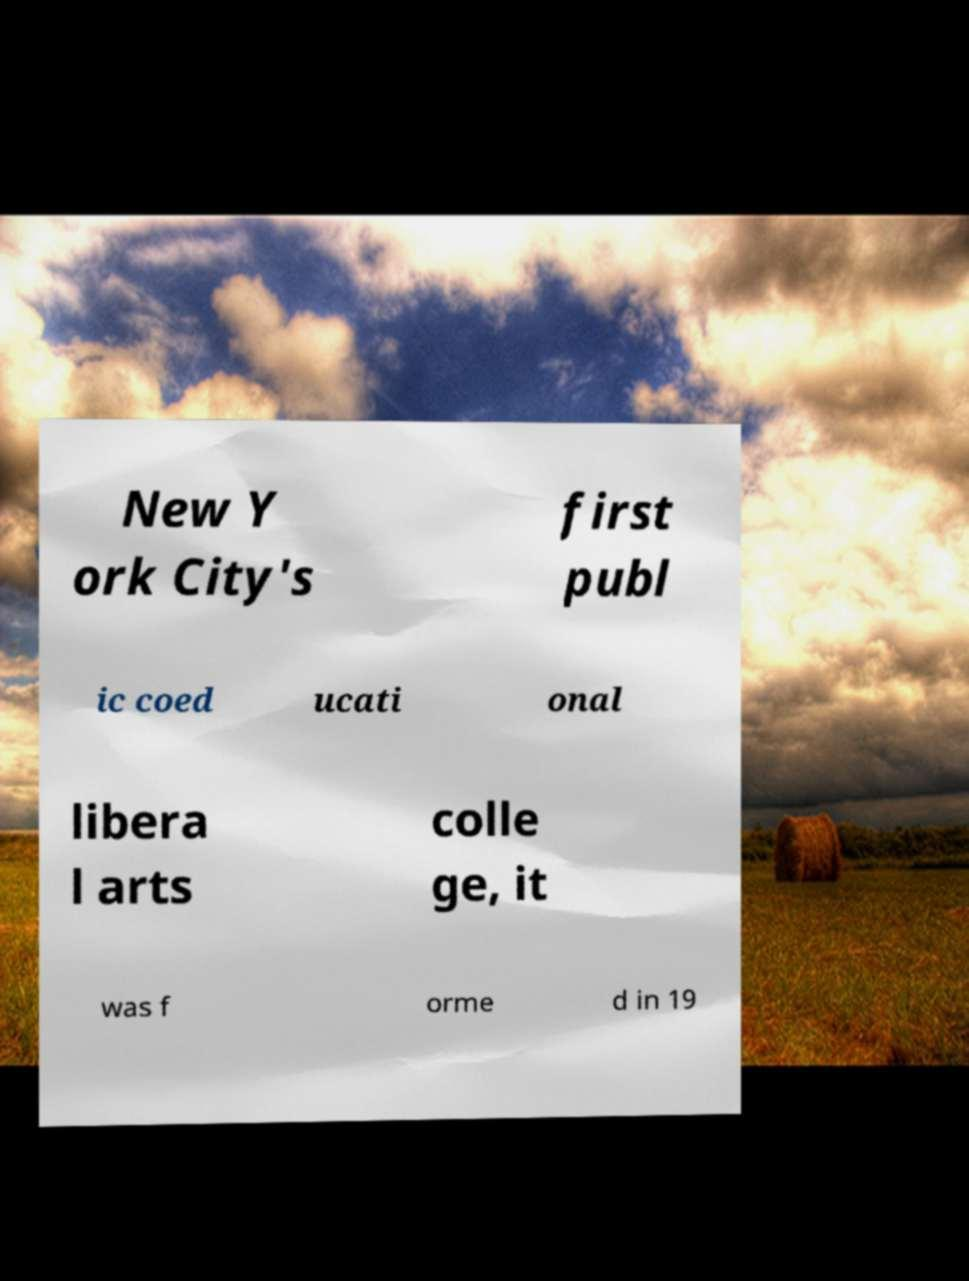There's text embedded in this image that I need extracted. Can you transcribe it verbatim? New Y ork City's first publ ic coed ucati onal libera l arts colle ge, it was f orme d in 19 